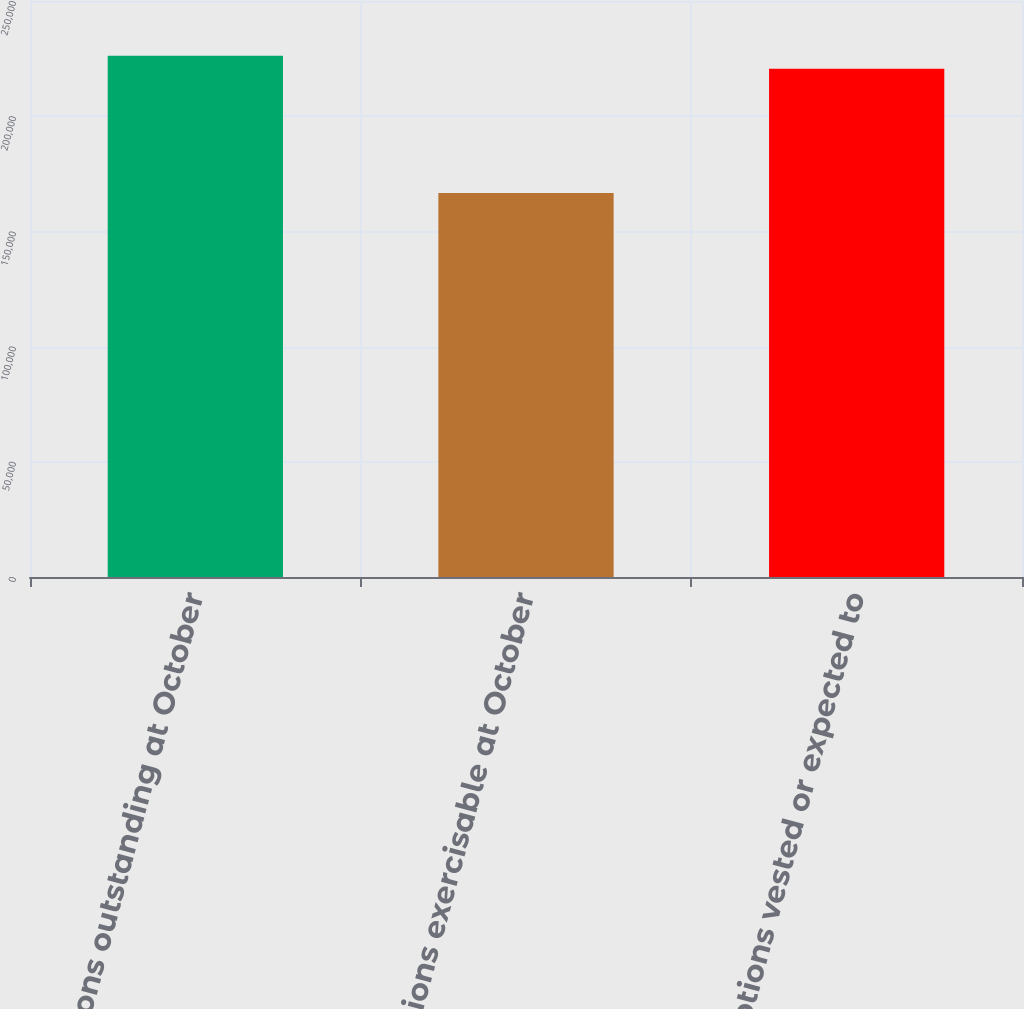Convert chart. <chart><loc_0><loc_0><loc_500><loc_500><bar_chart><fcel>Options outstanding at October<fcel>Options exercisable at October<fcel>Options vested or expected to<nl><fcel>226286<fcel>166673<fcel>220557<nl></chart> 